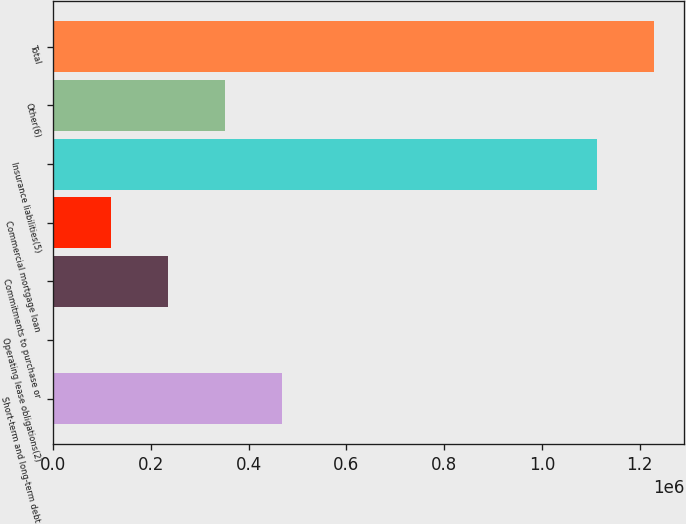Convert chart. <chart><loc_0><loc_0><loc_500><loc_500><bar_chart><fcel>Short-term and long-term debt<fcel>Operating lease obligations(2)<fcel>Commitments to purchase or<fcel>Commercial mortgage loan<fcel>Insurance liabilities(5)<fcel>Other(6)<fcel>Total<nl><fcel>468520<fcel>746<fcel>234633<fcel>117690<fcel>1.11235e+06<fcel>351577<fcel>1.2293e+06<nl></chart> 